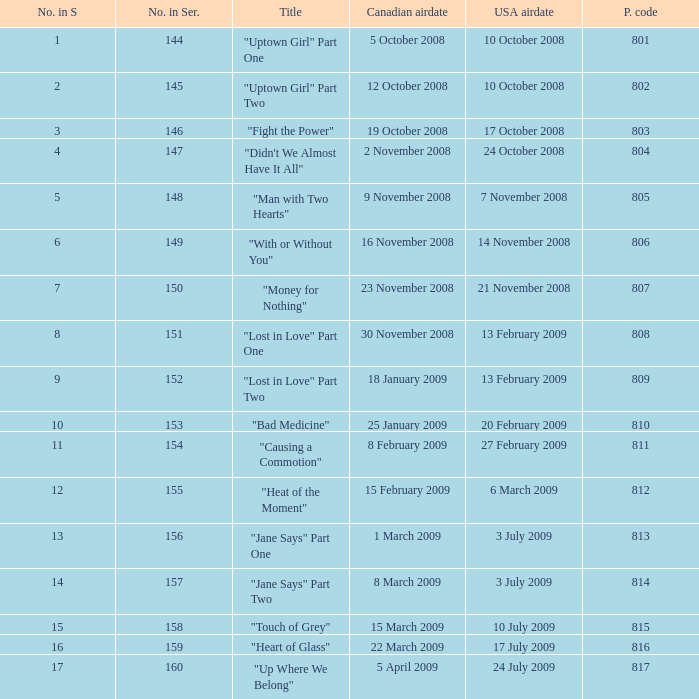How many U.S. air dates were from an episode in Season 4? 1.0. 